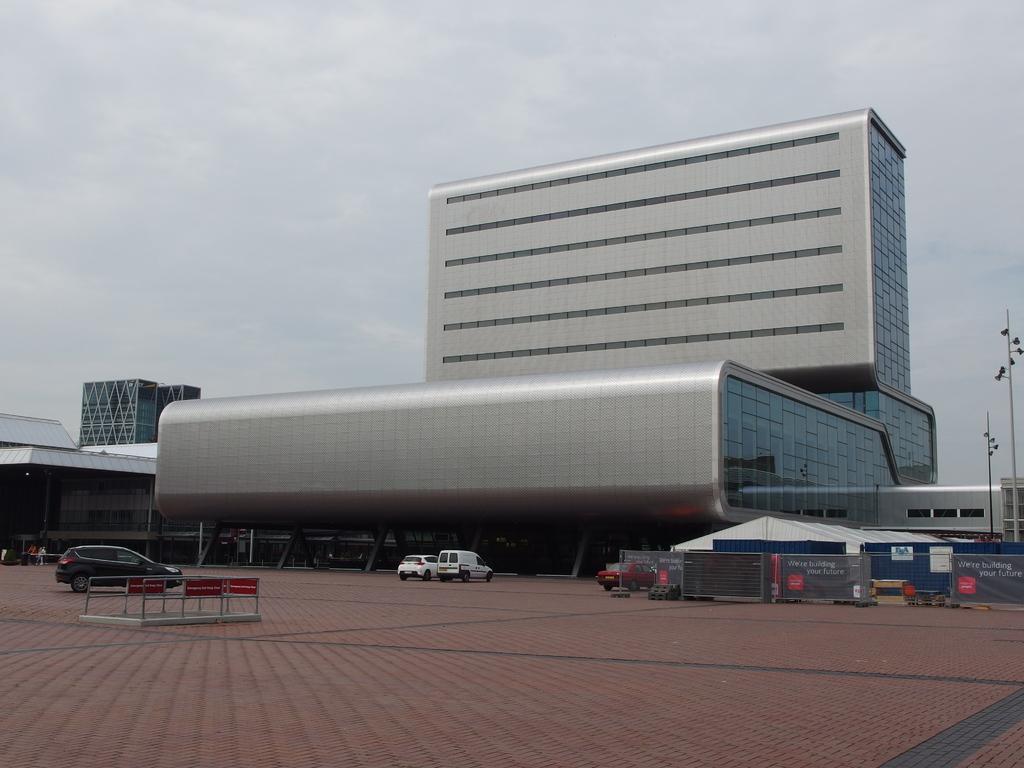Can you describe this image briefly? In the foreground of this picture, we can see the path to walk, vehicles moving on the path. In the background, there is fencing, shed, building, pole and the sky. 